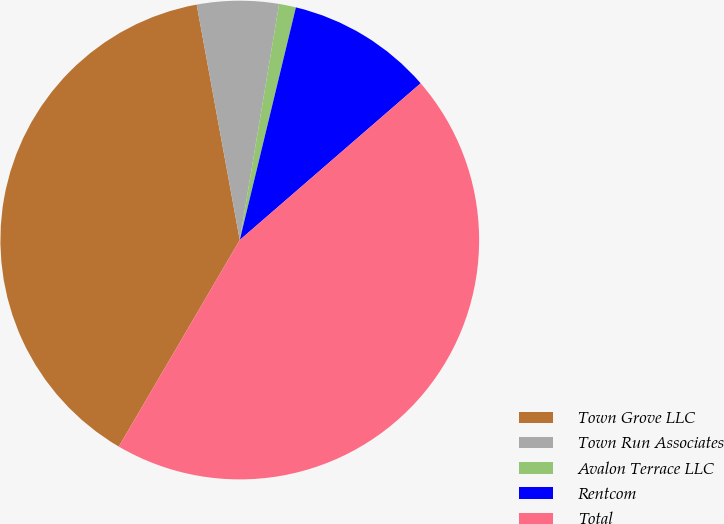Convert chart to OTSL. <chart><loc_0><loc_0><loc_500><loc_500><pie_chart><fcel>Town Grove LLC<fcel>Town Run Associates<fcel>Avalon Terrace LLC<fcel>Rentcom<fcel>Total<nl><fcel>38.69%<fcel>5.51%<fcel>1.14%<fcel>9.87%<fcel>44.8%<nl></chart> 